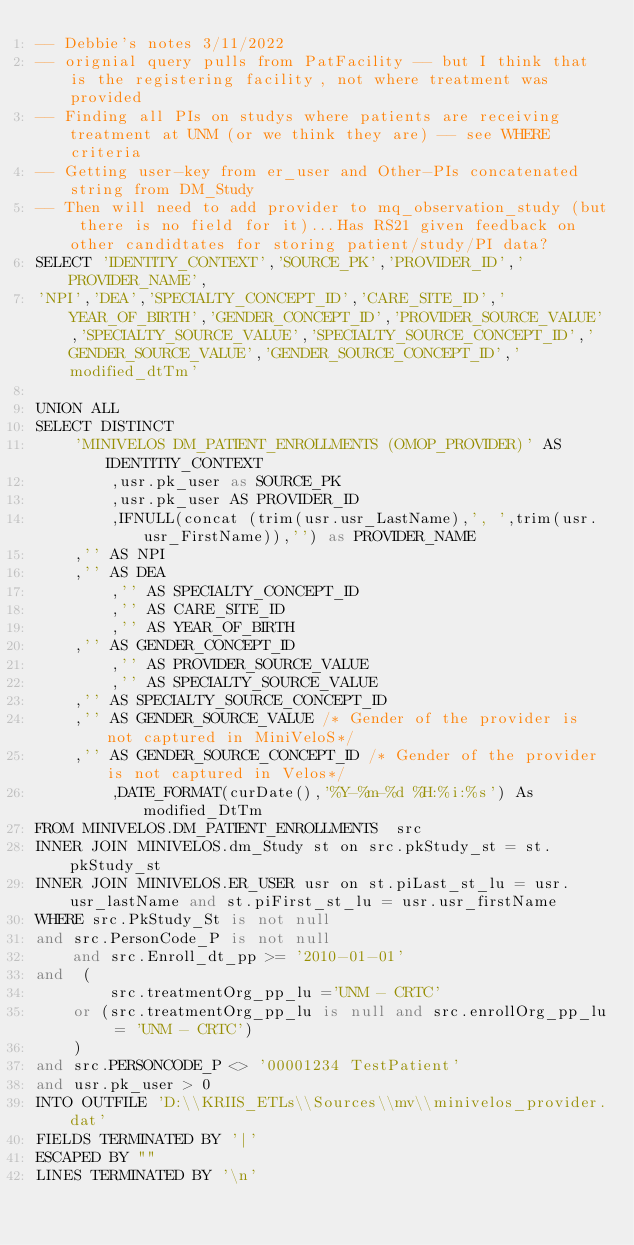<code> <loc_0><loc_0><loc_500><loc_500><_SQL_>-- Debbie's notes 3/11/2022
-- orignial query pulls from PatFacility -- but I think that is the registering facility, not where treatment was provided
-- Finding all PIs on studys where patients are receiving treatment at UNM (or we think they are) -- see WHERE criteria
-- Getting user-key from er_user and Other-PIs concatenated string from DM_Study
-- Then will need to add provider to mq_observation_study (but there is no field for it)...Has RS21 given feedback on other candidtates for storing patient/study/PI data?
SELECT 'IDENTITY_CONTEXT','SOURCE_PK','PROVIDER_ID','PROVIDER_NAME',
'NPI','DEA','SPECIALTY_CONCEPT_ID','CARE_SITE_ID','YEAR_OF_BIRTH','GENDER_CONCEPT_ID','PROVIDER_SOURCE_VALUE','SPECIALTY_SOURCE_VALUE','SPECIALTY_SOURCE_CONCEPT_ID','GENDER_SOURCE_VALUE','GENDER_SOURCE_CONCEPT_ID','modified_dtTm'

UNION ALL
SELECT DISTINCT
	'MINIVELOS DM_PATIENT_ENROLLMENTS (OMOP_PROVIDER)' AS IDENTITIY_CONTEXT
        ,usr.pk_user as SOURCE_PK
        ,usr.pk_user AS PROVIDER_ID
        ,IFNULL(concat (trim(usr.usr_LastName),', ',trim(usr.usr_FirstName)),'') as PROVIDER_NAME
	,'' AS NPI
	,'' AS DEA   
        ,'' AS SPECIALTY_CONCEPT_ID
        ,'' AS CARE_SITE_ID
        ,'' AS YEAR_OF_BIRTH
	,'' AS GENDER_CONCEPT_ID
        ,'' AS PROVIDER_SOURCE_VALUE
        ,'' AS SPECIALTY_SOURCE_VALUE 
	,'' AS SPECIALTY_SOURCE_CONCEPT_ID 
	,'' AS GENDER_SOURCE_VALUE /* Gender of the provider is not captured in MiniVeloS*/
	,'' AS GENDER_SOURCE_CONCEPT_ID /* Gender of the provider is not captured in Velos*/
        ,DATE_FORMAT(curDate(),'%Y-%m-%d %H:%i:%s') As modified_DtTm 
FROM MINIVELOS.DM_PATIENT_ENROLLMENTS  src
INNER JOIN MINIVELOS.dm_Study st on src.pkStudy_st = st.pkStudy_st
INNER JOIN MINIVELOS.ER_USER usr on st.piLast_st_lu = usr.usr_lastName and st.piFirst_st_lu = usr.usr_firstName
WHERE src.PkStudy_St is not null 
and src.PersonCode_P is not null
	and src.Enroll_dt_pp >= '2010-01-01'
and  (		
		src.treatmentOrg_pp_lu ='UNM - CRTC'   
    or (src.treatmentOrg_pp_lu is null and src.enrollOrg_pp_lu = 'UNM - CRTC')
    )   
and src.PERSONCODE_P <> '00001234 TestPatient'
and usr.pk_user > 0 
INTO OUTFILE 'D:\\KRIIS_ETLs\\Sources\\mv\\minivelos_provider.dat'
FIELDS TERMINATED BY '|'
ESCAPED BY "" 
LINES TERMINATED BY '\n'


</code> 